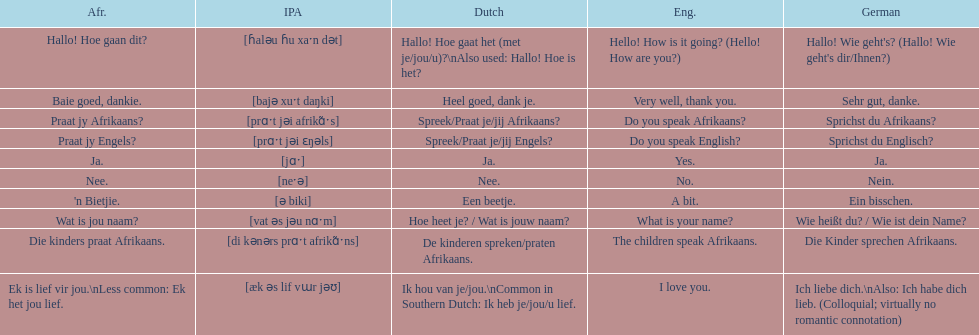How do you say 'i love you' in afrikaans? Ek is lief vir jou. 